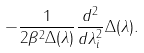Convert formula to latex. <formula><loc_0><loc_0><loc_500><loc_500>- \frac { 1 } { 2 \beta ^ { 2 } \Delta ( \lambda ) } \frac { d ^ { 2 } } { d \lambda _ { i } ^ { 2 } } \Delta ( \lambda ) .</formula> 